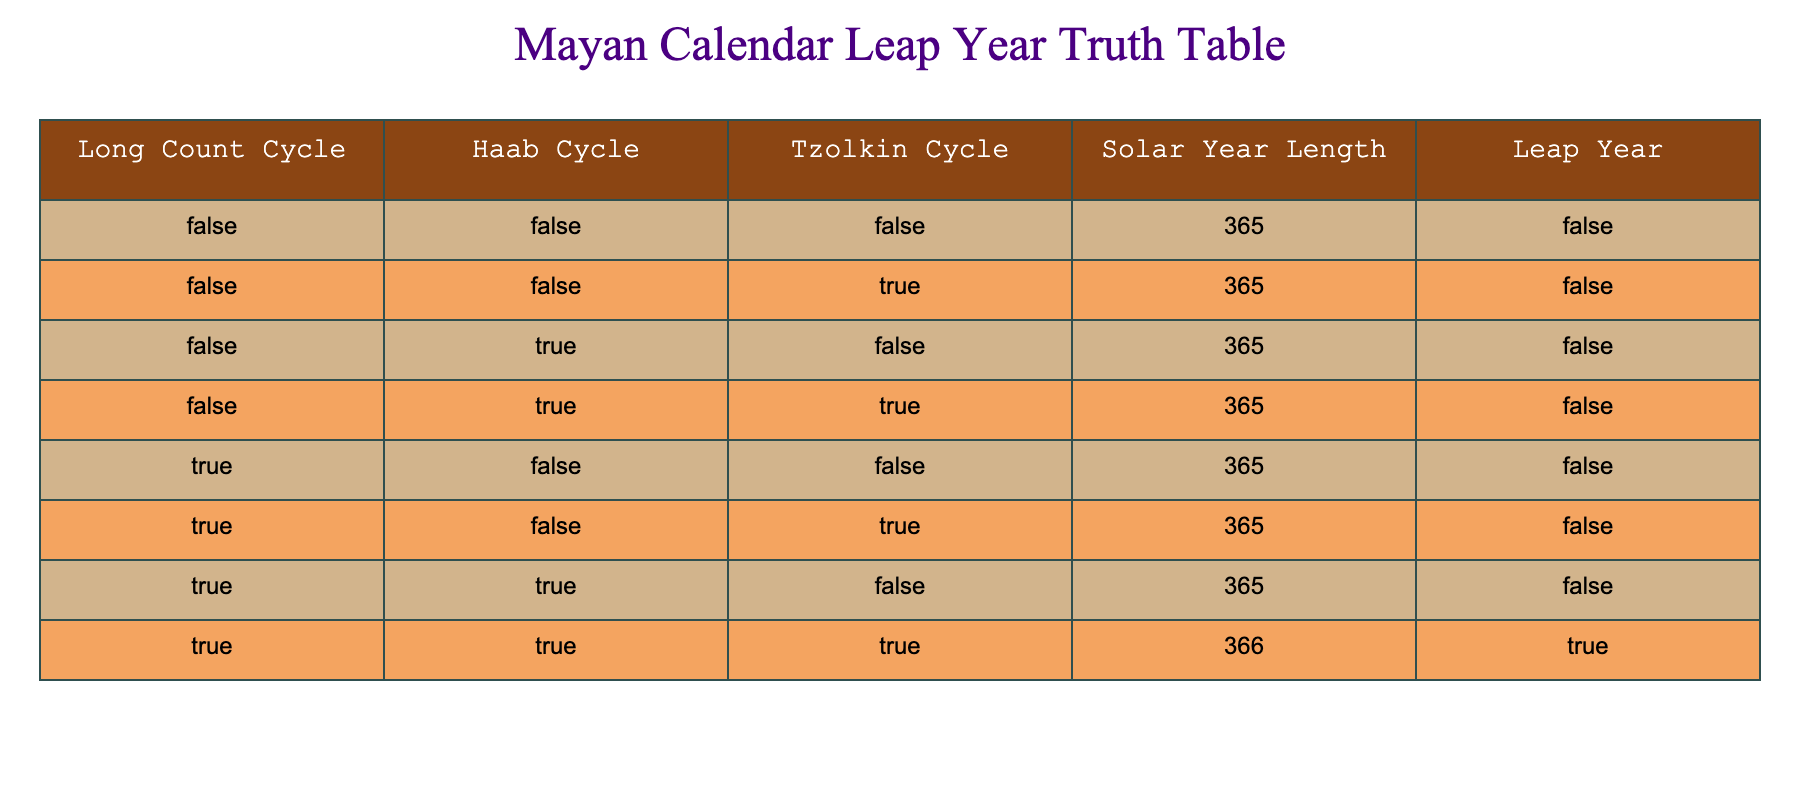What is the solar year length for the Tzolkin cycle of true? In the row where the Tzolkin cycle is true, the solar year length is listed as 366.
Answer: 366 How many combinations yield a leap year in the Mayan calendar table? Only one combination of True for Long Count, True for Haab, and True for Tzolkin results in a leap year. Therefore, there is only one combination.
Answer: 1 Is there a leap year when the Long Count is false and the Haab is false? Looking at the rows where both Long Count and Haab are false, the leap year value is consistently false across all such combinations.
Answer: No What is the leap year status when Haab is true and Tzolkin is false? In the two rows where Haab is true and Tzolkin is false, leap year status remains false for both instances.
Answer: False What is the average solar year length for the rows with Tzolkin as true? The solar year lengths for Tzolkin true are 365 (twice) and 366 (once), totaling 1096. Dividing 1096 by 3 gives an average of approximately 365.33.
Answer: 365.33 How many combinations have both Long Count and Tzolkin as false? There are four instances in the table where both Long Count and Tzolkin are false (4 occurrences).
Answer: 4 If the Long Count is true, what is the probability of having a leap year? Out of the four rows where the Long Count is true, only one has a leap year. Hence, the probability is 1 out of 4, which is 0.25 or 25%.
Answer: 25% Can there be a leap year with only Haab being true? Referencing the row where Haab is true, but Tzolkin is false (365), it confirms that a leap year cannot occur in that scenario.
Answer: No 